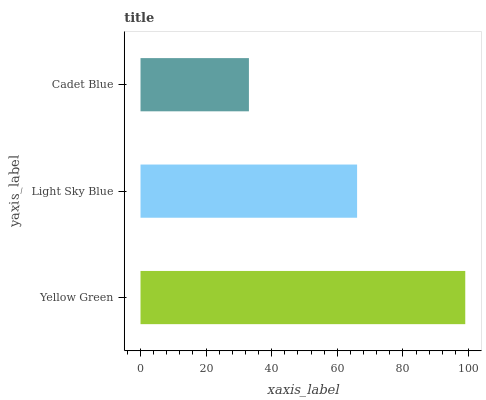Is Cadet Blue the minimum?
Answer yes or no. Yes. Is Yellow Green the maximum?
Answer yes or no. Yes. Is Light Sky Blue the minimum?
Answer yes or no. No. Is Light Sky Blue the maximum?
Answer yes or no. No. Is Yellow Green greater than Light Sky Blue?
Answer yes or no. Yes. Is Light Sky Blue less than Yellow Green?
Answer yes or no. Yes. Is Light Sky Blue greater than Yellow Green?
Answer yes or no. No. Is Yellow Green less than Light Sky Blue?
Answer yes or no. No. Is Light Sky Blue the high median?
Answer yes or no. Yes. Is Light Sky Blue the low median?
Answer yes or no. Yes. Is Cadet Blue the high median?
Answer yes or no. No. Is Cadet Blue the low median?
Answer yes or no. No. 